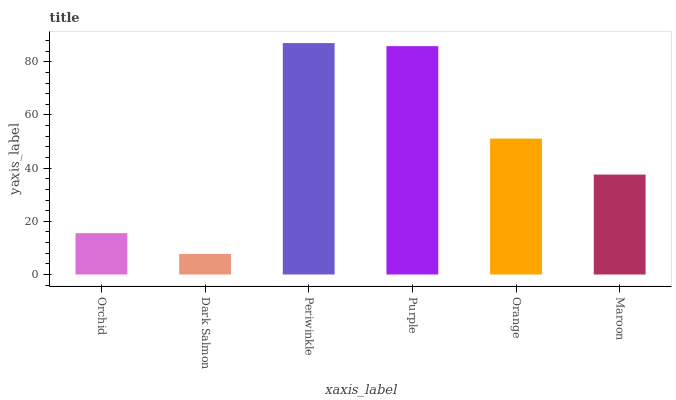Is Dark Salmon the minimum?
Answer yes or no. Yes. Is Periwinkle the maximum?
Answer yes or no. Yes. Is Periwinkle the minimum?
Answer yes or no. No. Is Dark Salmon the maximum?
Answer yes or no. No. Is Periwinkle greater than Dark Salmon?
Answer yes or no. Yes. Is Dark Salmon less than Periwinkle?
Answer yes or no. Yes. Is Dark Salmon greater than Periwinkle?
Answer yes or no. No. Is Periwinkle less than Dark Salmon?
Answer yes or no. No. Is Orange the high median?
Answer yes or no. Yes. Is Maroon the low median?
Answer yes or no. Yes. Is Dark Salmon the high median?
Answer yes or no. No. Is Orange the low median?
Answer yes or no. No. 